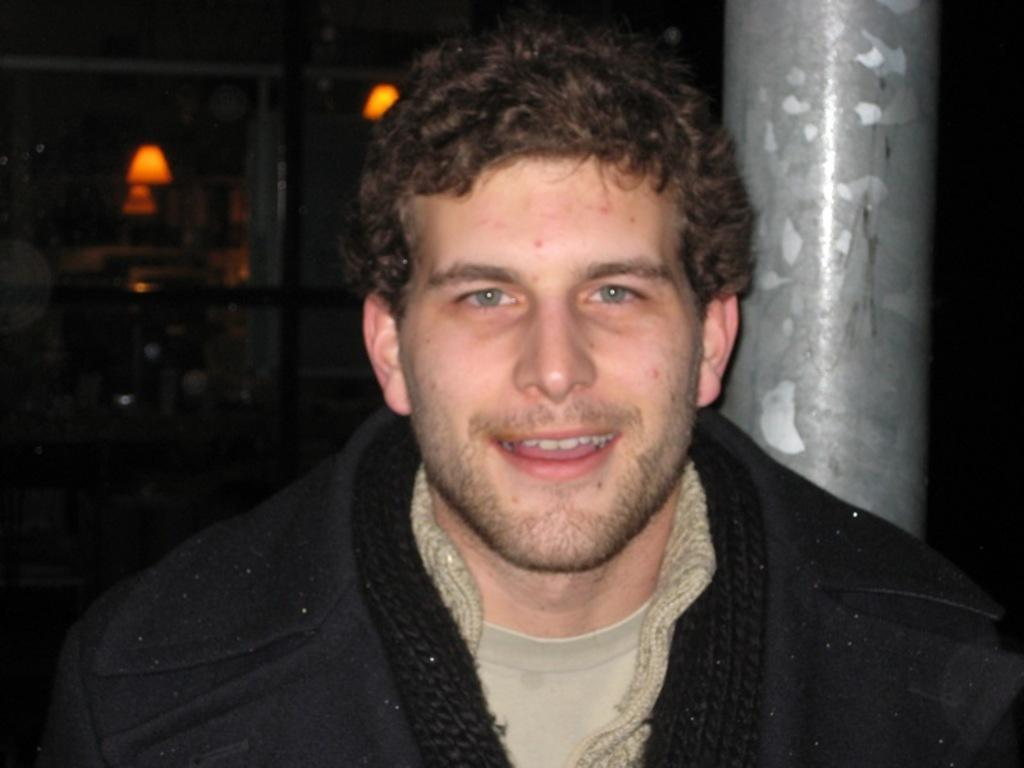Who is the main subject in the image? There is a man in the middle of the image. What is the man's facial expression? The man has a smiling face. How would you describe the overall lighting in the image? The background of the image is dark. Can you identify any objects in the image besides the man? Yes, there are two lamps and a pillar in the image. What type of duck can be seen sitting on the man's shoulder in the image? There is no duck present in the image; the man is alone in the image. What body part of the man is injured in the image? There is no indication of any injury to the man in the image. 